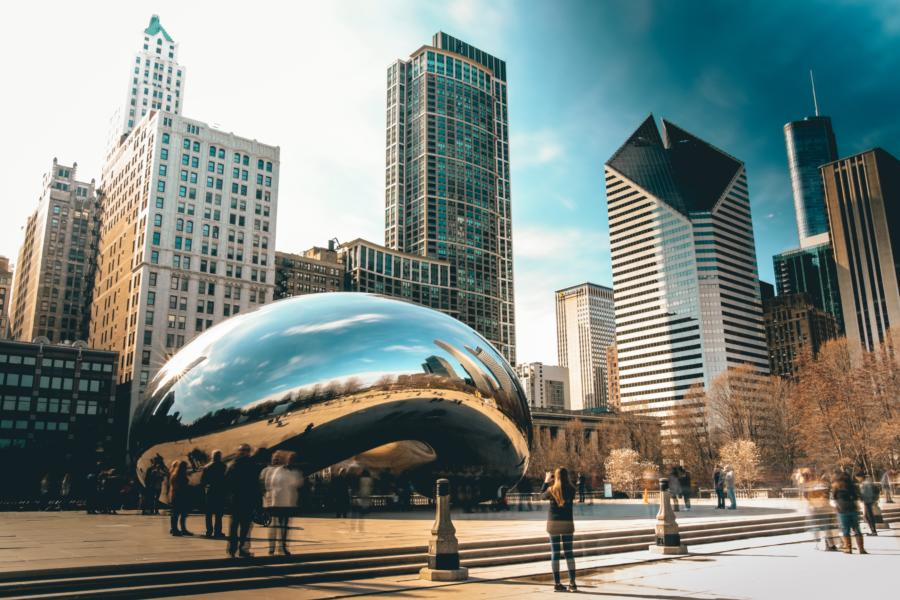Can you elaborate on the elements of the picture provided? The image showcases the Cloud Gate sculpture, often affectionately called 'The Bean,' located in Chicago's Millennium Park. This iconic sculpture is crafted from highly polished stainless steel, which reflects the city's skyline and the sky above in its seamless, mirror-like surface. From the image's angle, The Bean looms large with a backdrop of varied architecture, from sleek, modern skyscrapers to historic stone towers. The scene is vibrant with visitors, capturing a spirit of urban exploration and interaction. Furthermore, you can notice the play of light and shadow, highlighting the fluid design of the sculpture and the dynamic contrasts of city life around it. 